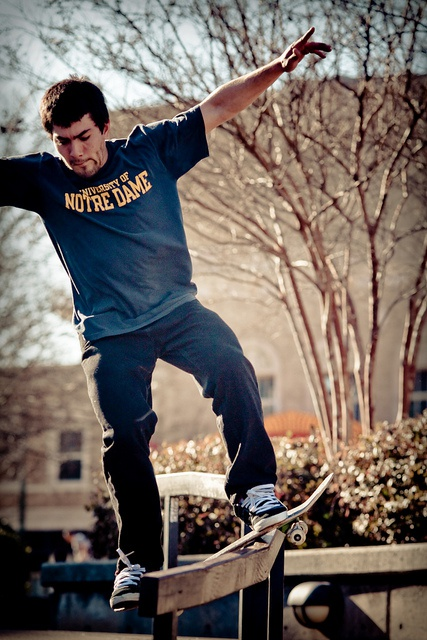Describe the objects in this image and their specific colors. I can see people in gray, black, navy, blue, and brown tones and skateboard in gray, ivory, black, and tan tones in this image. 